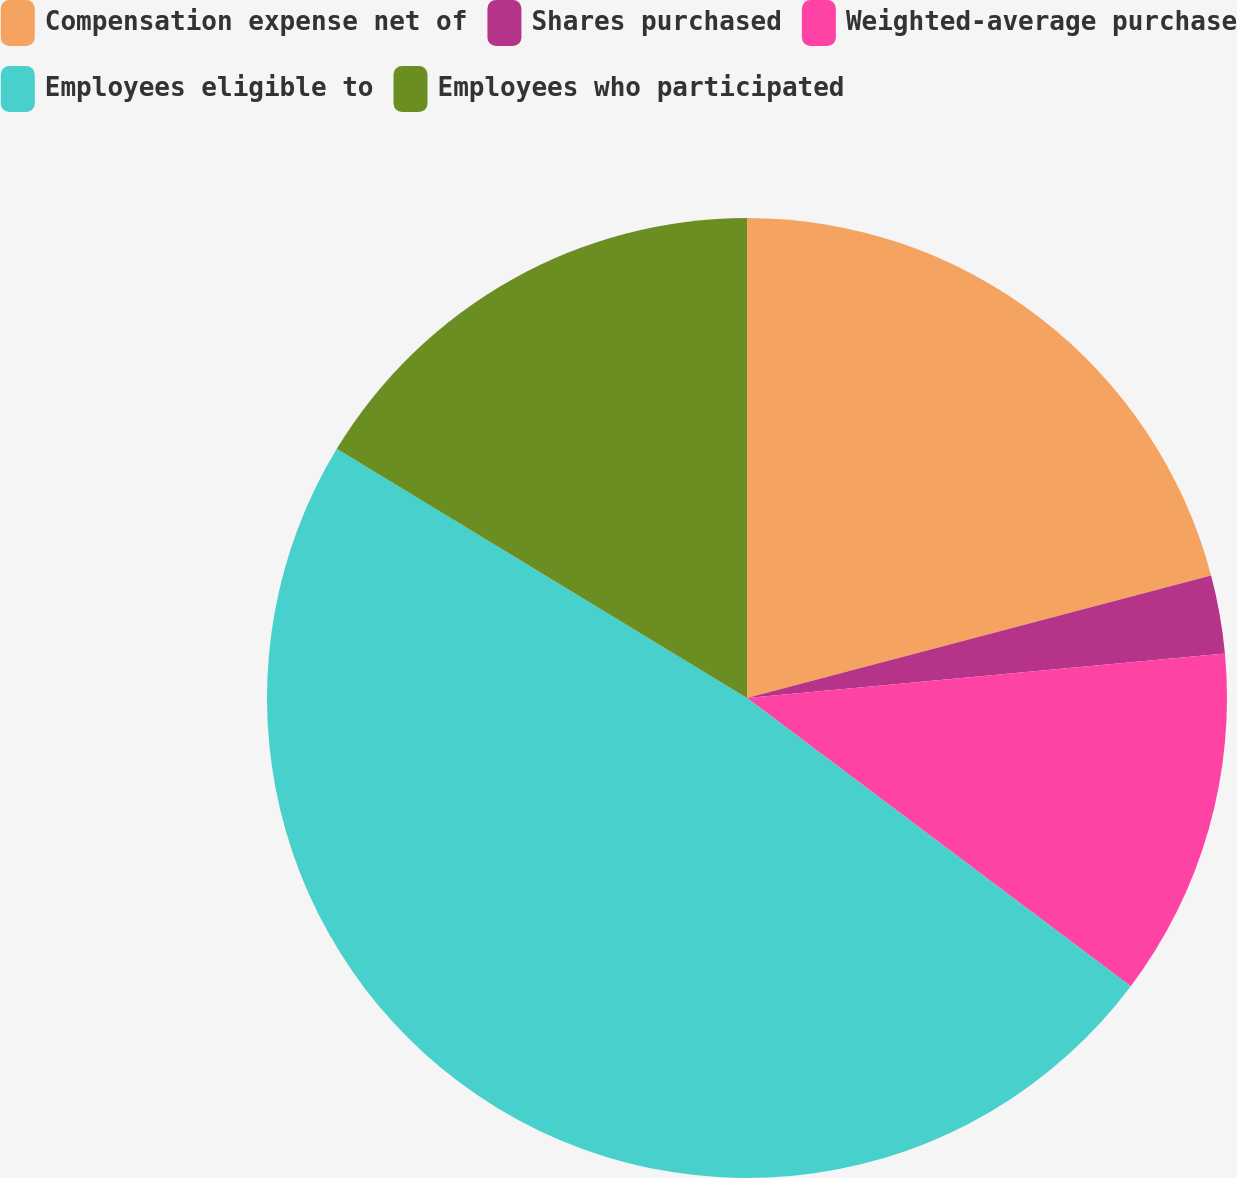Convert chart to OTSL. <chart><loc_0><loc_0><loc_500><loc_500><pie_chart><fcel>Compensation expense net of<fcel>Shares purchased<fcel>Weighted-average purchase<fcel>Employees eligible to<fcel>Employees who participated<nl><fcel>20.89%<fcel>2.63%<fcel>11.73%<fcel>48.43%<fcel>16.31%<nl></chart> 